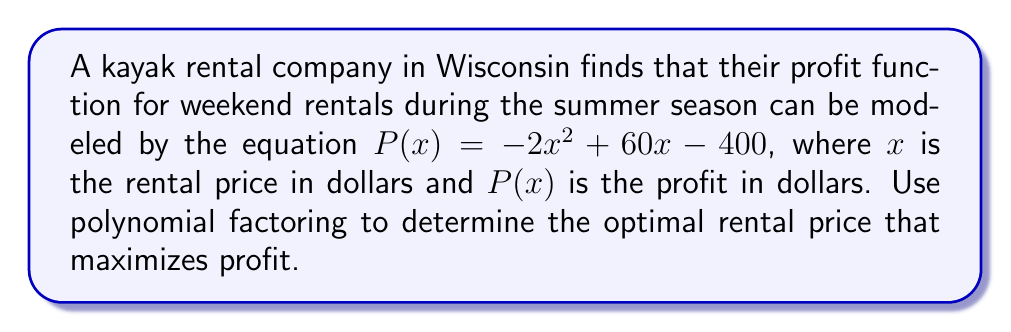Help me with this question. 1) The profit function $P(x) = -2x^2 + 60x - 400$ is a quadratic equation. The maximum of a quadratic function occurs at the axis of symmetry.

2) To find the axis of symmetry, we can use the formula $x = -\frac{b}{2a}$, where $a$ and $b$ are the coefficients of the quadratic equation in standard form $(ax^2 + bx + c)$.

3) In this case, $a = -2$ and $b = 60$. Let's substitute these values:

   $x = -\frac{60}{2(-2)} = -\frac{60}{-4} = 15$

4) To verify this result using factoring:

   $P(x) = -2x^2 + 60x - 400$
   $     = -2(x^2 - 30x) - 400$
   $     = -2(x - 15)^2 + 50$

5) The factored form confirms that the vertex (and thus the maximum) occurs at $x = 15$.

6) Therefore, the optimal rental price is $15.
Answer: $15 